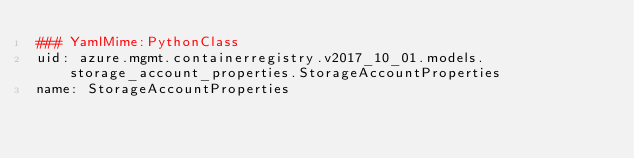Convert code to text. <code><loc_0><loc_0><loc_500><loc_500><_YAML_>### YamlMime:PythonClass
uid: azure.mgmt.containerregistry.v2017_10_01.models.storage_account_properties.StorageAccountProperties
name: StorageAccountProperties</code> 